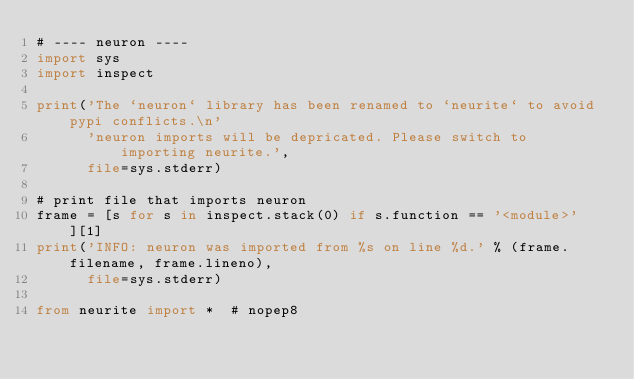<code> <loc_0><loc_0><loc_500><loc_500><_Python_># ---- neuron ----
import sys
import inspect

print('The `neuron` library has been renamed to `neurite` to avoid pypi conflicts.\n'
      'neuron imports will be depricated. Please switch to importing neurite.',
      file=sys.stderr)

# print file that imports neuron
frame = [s for s in inspect.stack(0) if s.function == '<module>'][1]
print('INFO: neuron was imported from %s on line %d.' % (frame.filename, frame.lineno),
      file=sys.stderr)

from neurite import *  # nopep8
</code> 